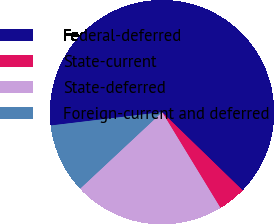Convert chart to OTSL. <chart><loc_0><loc_0><loc_500><loc_500><pie_chart><fcel>Federal-deferred<fcel>State-current<fcel>State-deferred<fcel>Foreign-current and deferred<nl><fcel>64.16%<fcel>4.03%<fcel>21.76%<fcel>10.05%<nl></chart> 